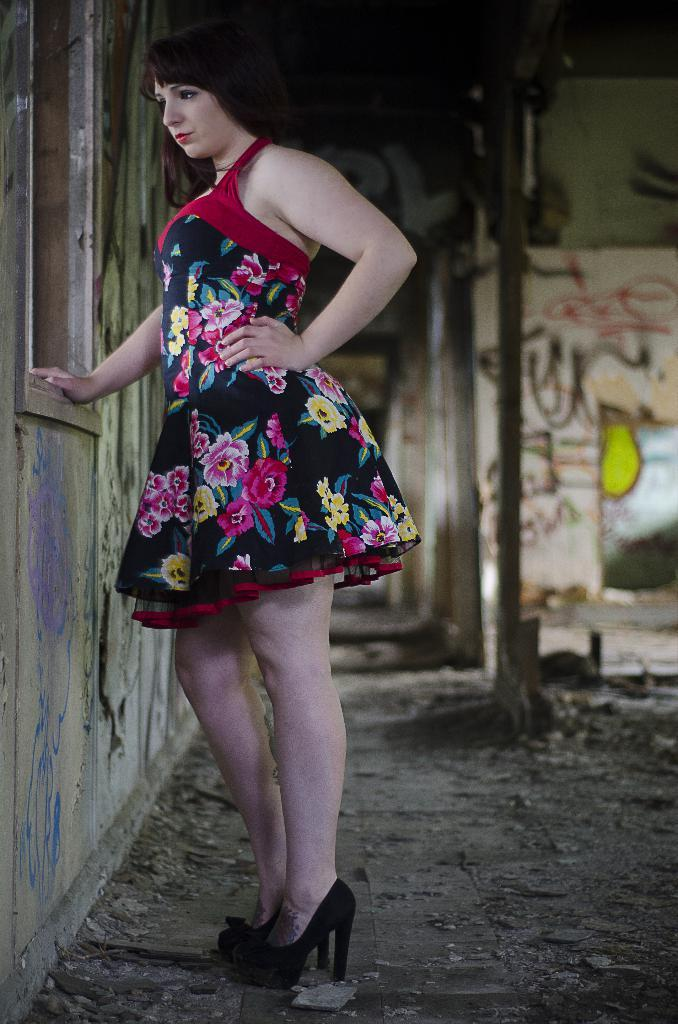What is the main subject of the image? There is a woman standing in the image. Where is the woman standing? The woman is standing on the ground. What is near the woman in the image? The woman is near a window. What can be seen in the background of the image? There are drawings on the wall in the background of the image. What type of glove is the woman wearing in the image? There is no glove visible in the image; the woman is not wearing any gloves. 